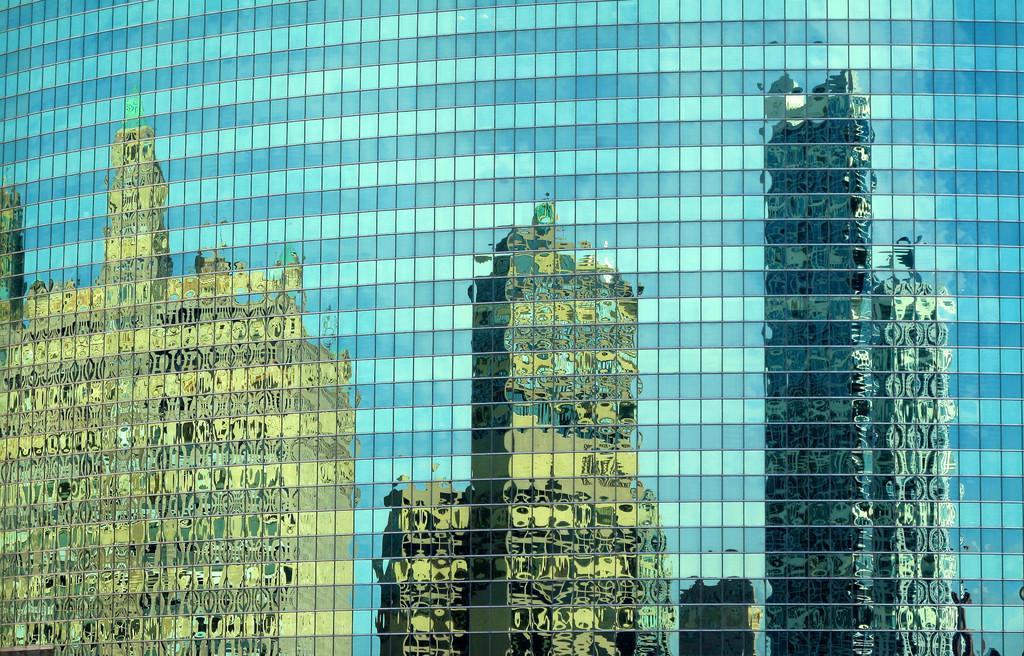Please provide a concise description of this image. In this image there is a building having the reflection of few buildings on it. 